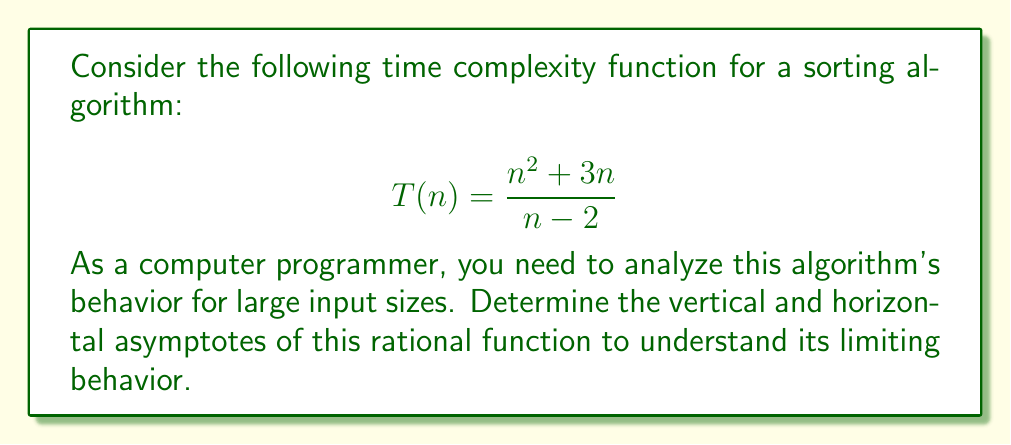What is the answer to this math problem? To find the asymptotes of the rational function, we'll follow these steps:

1. Vertical asymptote:
   Set the denominator to zero and solve for n.
   $n - 2 = 0$
   $n = 2$
   The vertical asymptote is at $x = 2$.

2. Horizontal asymptote:
   Compare the degrees of the numerator and denominator.
   Numerator degree: 2
   Denominator degree: 1
   Since the degree of the numerator is greater than the degree of the denominator, there is no horizontal asymptote. Instead, we have a slant asymptote.

3. Slant asymptote:
   To find the slant asymptote, perform polynomial long division:

   $$\frac{n^2 + 3n}{n - 2} = n + 5 + \frac{10}{n - 2}$$

   The slant asymptote is $y = n + 5$.

4. Interpretation for algorithm analysis:
   As n approaches infinity, the time complexity approaches the slant asymptote $T(n) \approx n + 5$.
   This indicates that for large input sizes, the algorithm's time complexity grows linearly with a slope of 1 and a y-intercept of 5.
Answer: Vertical asymptote: $x = 2$
Slant asymptote: $y = n + 5$ 